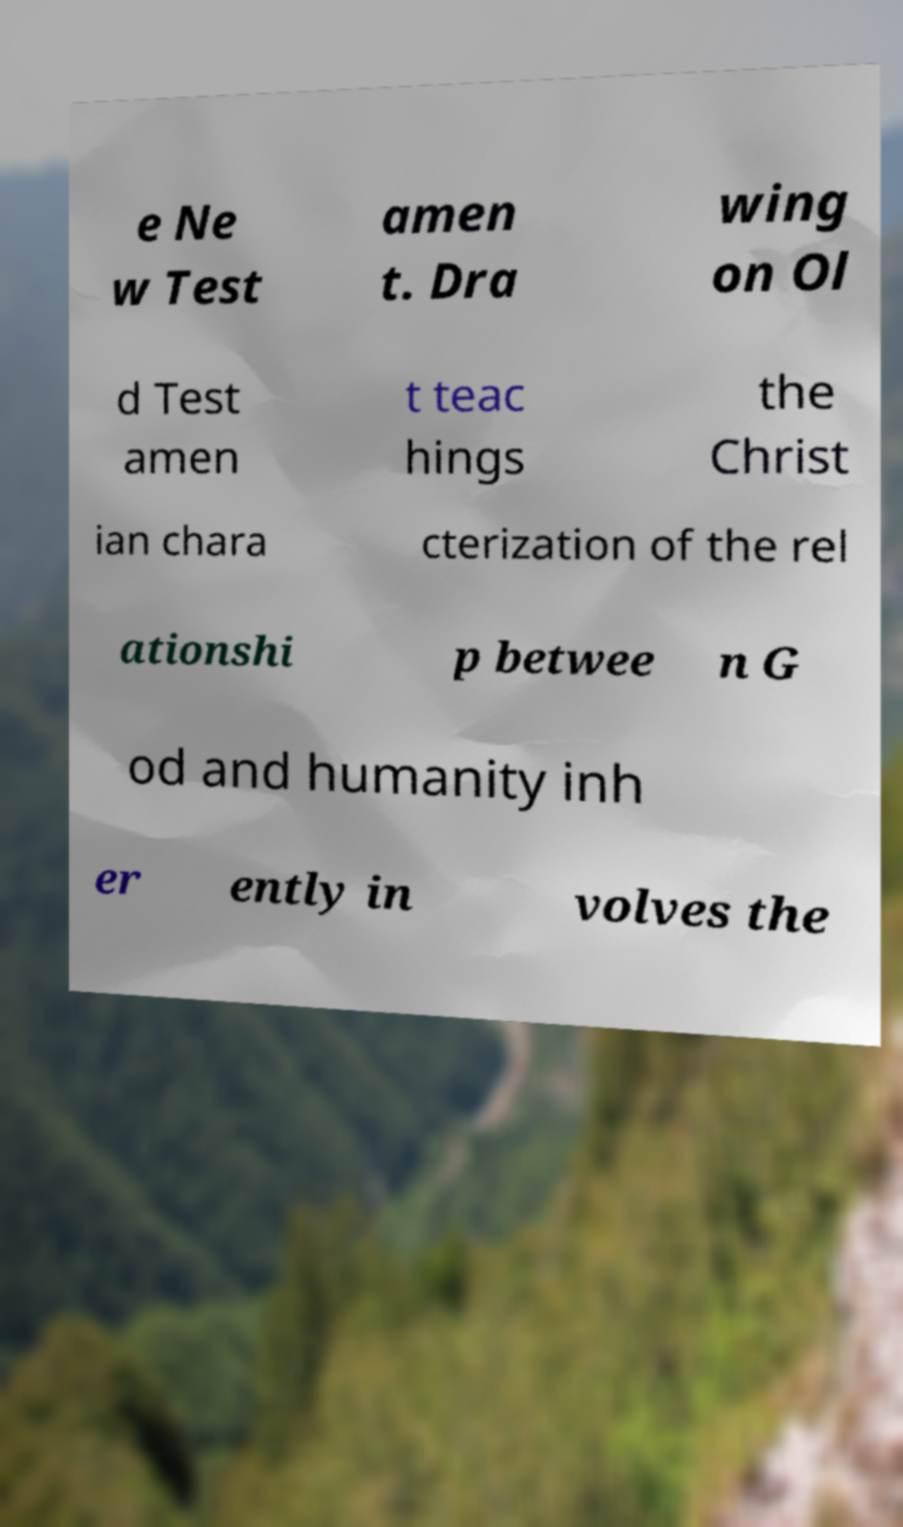For documentation purposes, I need the text within this image transcribed. Could you provide that? e Ne w Test amen t. Dra wing on Ol d Test amen t teac hings the Christ ian chara cterization of the rel ationshi p betwee n G od and humanity inh er ently in volves the 